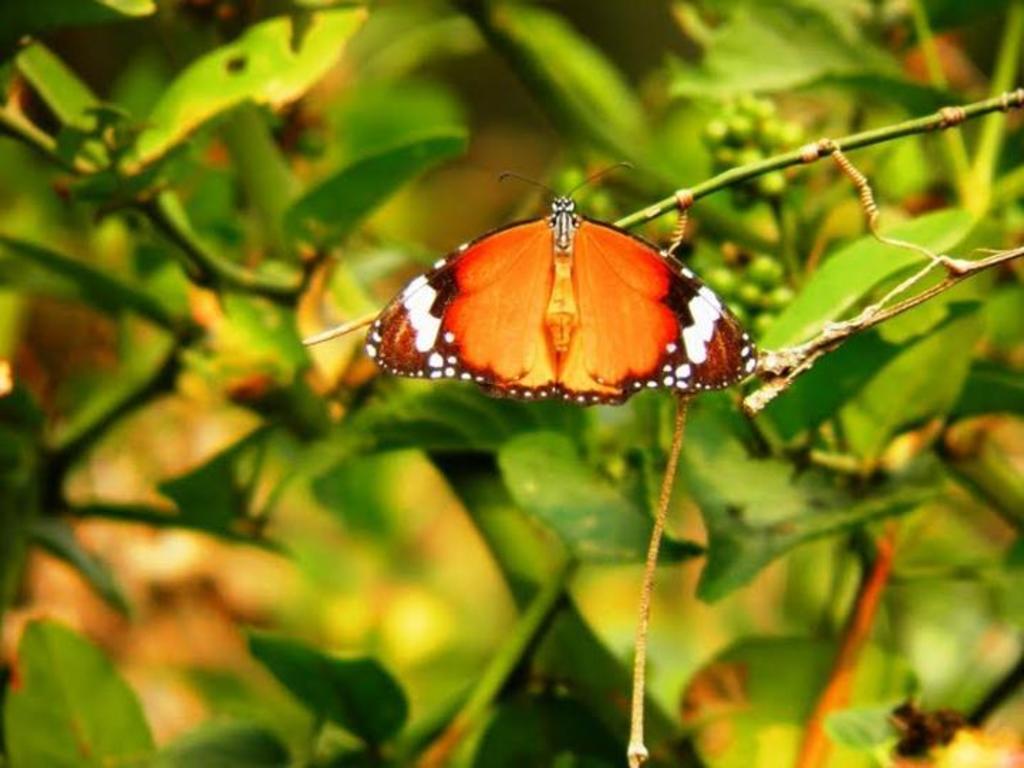Can you describe this image briefly? In this picture I can see a butterfly on a stem and I see that it is blurred in the background and I see number of leaves. 